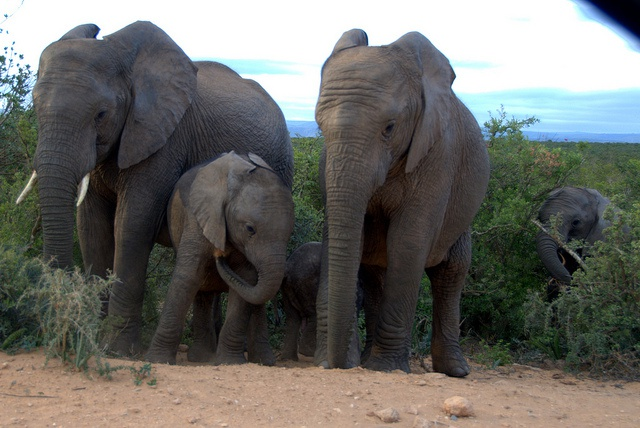Describe the objects in this image and their specific colors. I can see elephant in white, black, and gray tones, elephant in white, black, and gray tones, elephant in white, black, and gray tones, elephant in white, black, gray, and purple tones, and elephant in white, black, and gray tones in this image. 